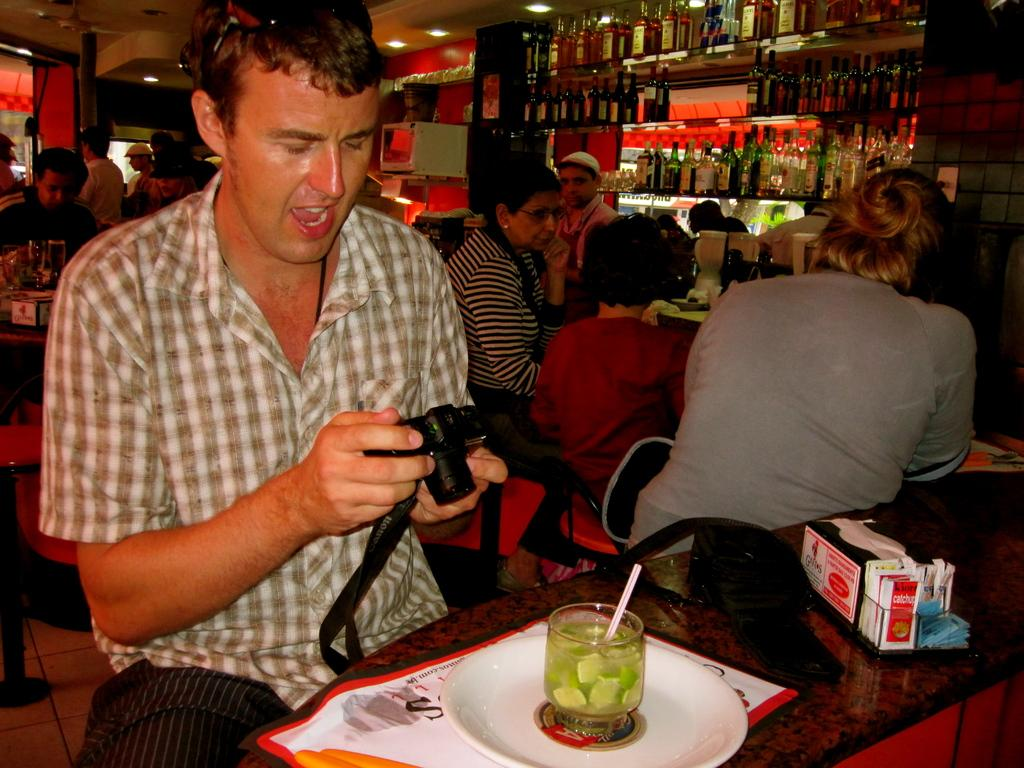How many people are in the image? There is a group of people in the image, but the exact number cannot be determined from the provided facts. What is on the table in the image? There is a plate, a banner, and a spoon on the table in the image. What is the purpose of the banner on the table? The purpose of the banner on the table cannot be determined from the provided facts. What is visible in the background of the image? In the background of the image, there is a wine shop. What type of tin can be seen in the image? There is no tin present in the image. What is the range of the earthquake that occurred during the event in the image? There is no mention of an earthquake in the image or the provided facts. 